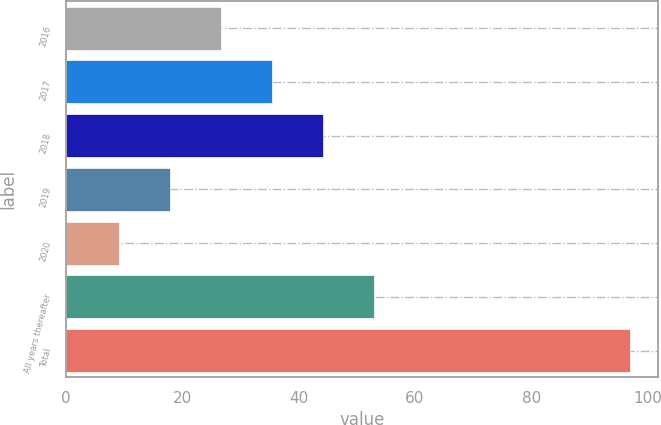<chart> <loc_0><loc_0><loc_500><loc_500><bar_chart><fcel>2016<fcel>2017<fcel>2018<fcel>2019<fcel>2020<fcel>All years thereafter<fcel>Total<nl><fcel>26.6<fcel>35.4<fcel>44.2<fcel>17.8<fcel>9<fcel>53<fcel>97<nl></chart> 